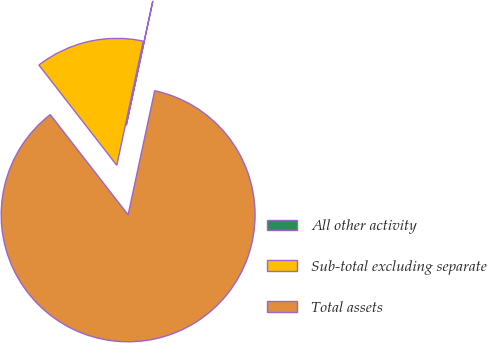Convert chart. <chart><loc_0><loc_0><loc_500><loc_500><pie_chart><fcel>All other activity<fcel>Sub-total excluding separate<fcel>Total assets<nl><fcel>0.01%<fcel>13.86%<fcel>86.13%<nl></chart> 